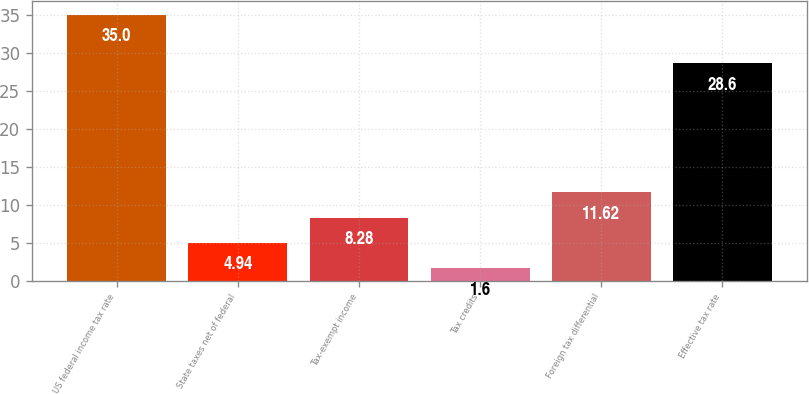Convert chart. <chart><loc_0><loc_0><loc_500><loc_500><bar_chart><fcel>US federal income tax rate<fcel>State taxes net of federal<fcel>Tax-exempt income<fcel>Tax credits<fcel>Foreign tax differential<fcel>Effective tax rate<nl><fcel>35<fcel>4.94<fcel>8.28<fcel>1.6<fcel>11.62<fcel>28.6<nl></chart> 